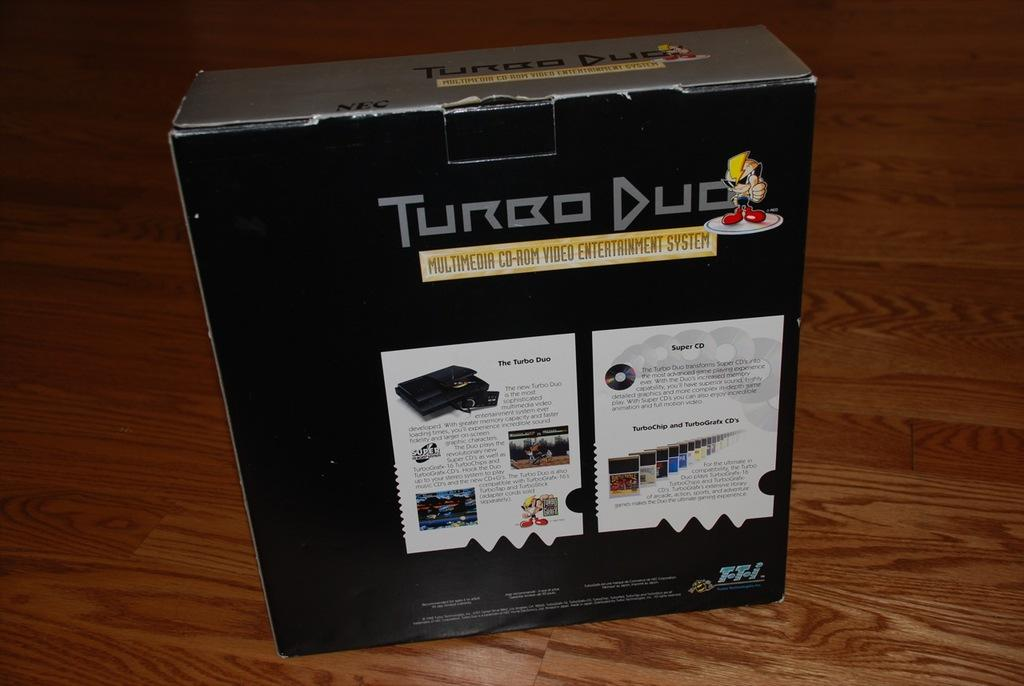<image>
Relay a brief, clear account of the picture shown. A box contains Turbo Duo, a multimedia CD-Rom video entertainment system. 